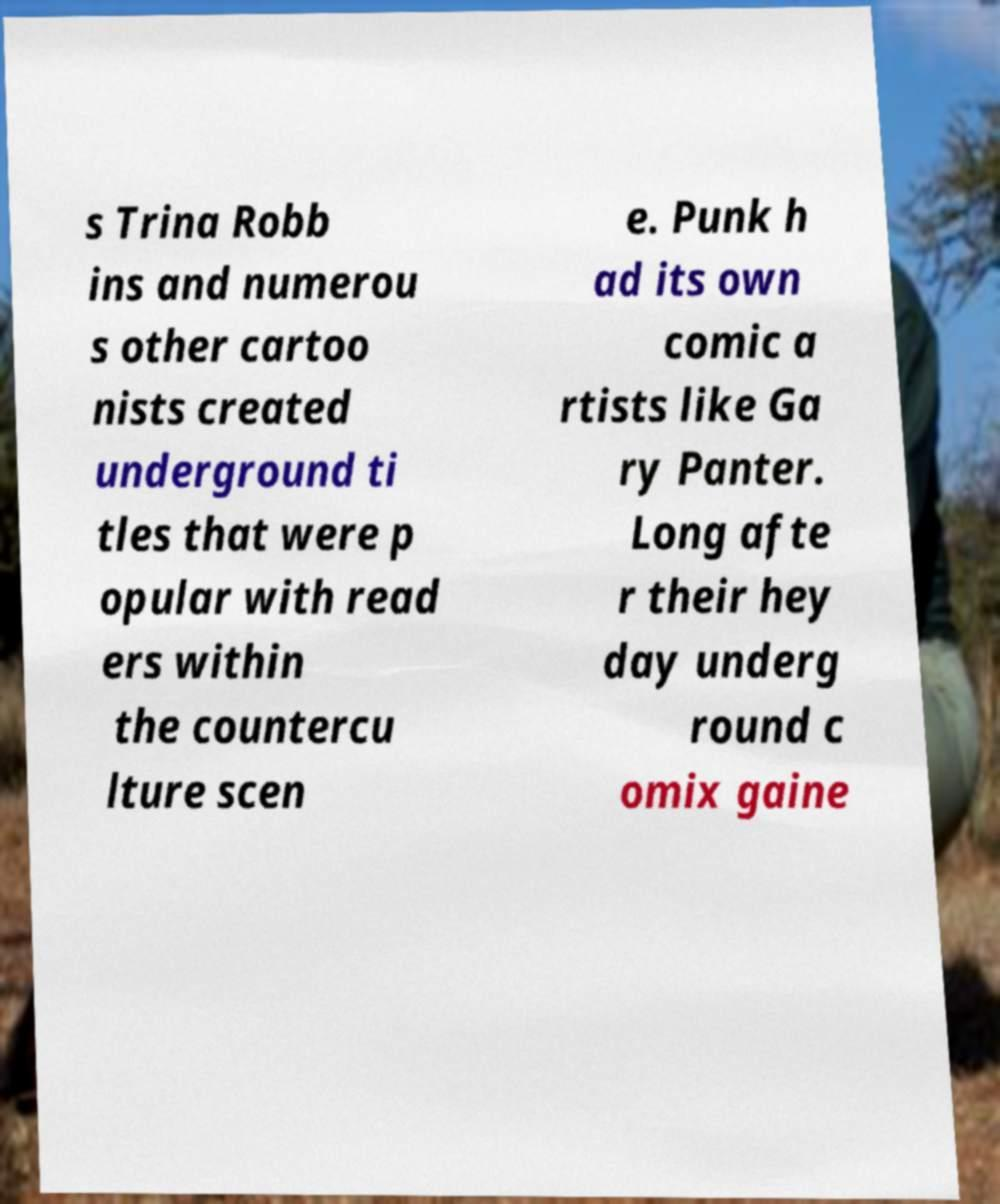Could you extract and type out the text from this image? s Trina Robb ins and numerou s other cartoo nists created underground ti tles that were p opular with read ers within the countercu lture scen e. Punk h ad its own comic a rtists like Ga ry Panter. Long afte r their hey day underg round c omix gaine 